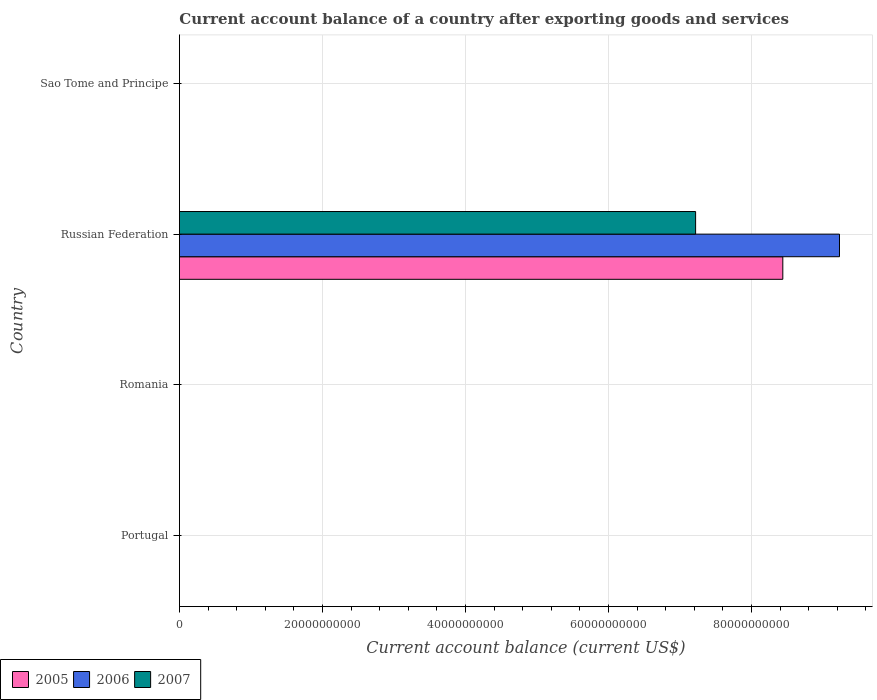How many bars are there on the 4th tick from the top?
Ensure brevity in your answer.  0. How many bars are there on the 4th tick from the bottom?
Offer a terse response. 0. What is the label of the 2nd group of bars from the top?
Give a very brief answer. Russian Federation. What is the account balance in 2005 in Sao Tome and Principe?
Your answer should be very brief. 0. Across all countries, what is the maximum account balance in 2006?
Make the answer very short. 9.23e+1. In which country was the account balance in 2007 maximum?
Make the answer very short. Russian Federation. What is the total account balance in 2007 in the graph?
Provide a succinct answer. 7.22e+1. What is the difference between the account balance in 2007 in Russian Federation and the account balance in 2005 in Portugal?
Offer a terse response. 7.22e+1. What is the average account balance in 2007 per country?
Your response must be concise. 1.80e+1. What is the difference between the account balance in 2007 and account balance in 2005 in Russian Federation?
Keep it short and to the point. -1.22e+1. What is the difference between the highest and the lowest account balance in 2007?
Offer a very short reply. 7.22e+1. Is it the case that in every country, the sum of the account balance in 2006 and account balance in 2007 is greater than the account balance in 2005?
Keep it short and to the point. No. How many countries are there in the graph?
Your answer should be very brief. 4. What is the difference between two consecutive major ticks on the X-axis?
Your response must be concise. 2.00e+1. Are the values on the major ticks of X-axis written in scientific E-notation?
Give a very brief answer. No. Where does the legend appear in the graph?
Make the answer very short. Bottom left. How many legend labels are there?
Your answer should be very brief. 3. How are the legend labels stacked?
Offer a terse response. Horizontal. What is the title of the graph?
Give a very brief answer. Current account balance of a country after exporting goods and services. Does "1993" appear as one of the legend labels in the graph?
Make the answer very short. No. What is the label or title of the X-axis?
Keep it short and to the point. Current account balance (current US$). What is the Current account balance (current US$) in 2006 in Portugal?
Ensure brevity in your answer.  0. What is the Current account balance (current US$) of 2007 in Portugal?
Keep it short and to the point. 0. What is the Current account balance (current US$) of 2007 in Romania?
Ensure brevity in your answer.  0. What is the Current account balance (current US$) in 2005 in Russian Federation?
Offer a terse response. 8.44e+1. What is the Current account balance (current US$) in 2006 in Russian Federation?
Offer a terse response. 9.23e+1. What is the Current account balance (current US$) in 2007 in Russian Federation?
Your answer should be compact. 7.22e+1. What is the Current account balance (current US$) in 2007 in Sao Tome and Principe?
Give a very brief answer. 0. Across all countries, what is the maximum Current account balance (current US$) in 2005?
Your answer should be compact. 8.44e+1. Across all countries, what is the maximum Current account balance (current US$) of 2006?
Offer a very short reply. 9.23e+1. Across all countries, what is the maximum Current account balance (current US$) of 2007?
Your answer should be very brief. 7.22e+1. Across all countries, what is the minimum Current account balance (current US$) in 2007?
Keep it short and to the point. 0. What is the total Current account balance (current US$) in 2005 in the graph?
Ensure brevity in your answer.  8.44e+1. What is the total Current account balance (current US$) of 2006 in the graph?
Your answer should be very brief. 9.23e+1. What is the total Current account balance (current US$) in 2007 in the graph?
Keep it short and to the point. 7.22e+1. What is the average Current account balance (current US$) of 2005 per country?
Ensure brevity in your answer.  2.11e+1. What is the average Current account balance (current US$) in 2006 per country?
Give a very brief answer. 2.31e+1. What is the average Current account balance (current US$) of 2007 per country?
Offer a very short reply. 1.80e+1. What is the difference between the Current account balance (current US$) of 2005 and Current account balance (current US$) of 2006 in Russian Federation?
Offer a terse response. -7.93e+09. What is the difference between the Current account balance (current US$) of 2005 and Current account balance (current US$) of 2007 in Russian Federation?
Keep it short and to the point. 1.22e+1. What is the difference between the Current account balance (current US$) in 2006 and Current account balance (current US$) in 2007 in Russian Federation?
Offer a very short reply. 2.01e+1. What is the difference between the highest and the lowest Current account balance (current US$) in 2005?
Your answer should be very brief. 8.44e+1. What is the difference between the highest and the lowest Current account balance (current US$) in 2006?
Make the answer very short. 9.23e+1. What is the difference between the highest and the lowest Current account balance (current US$) of 2007?
Ensure brevity in your answer.  7.22e+1. 